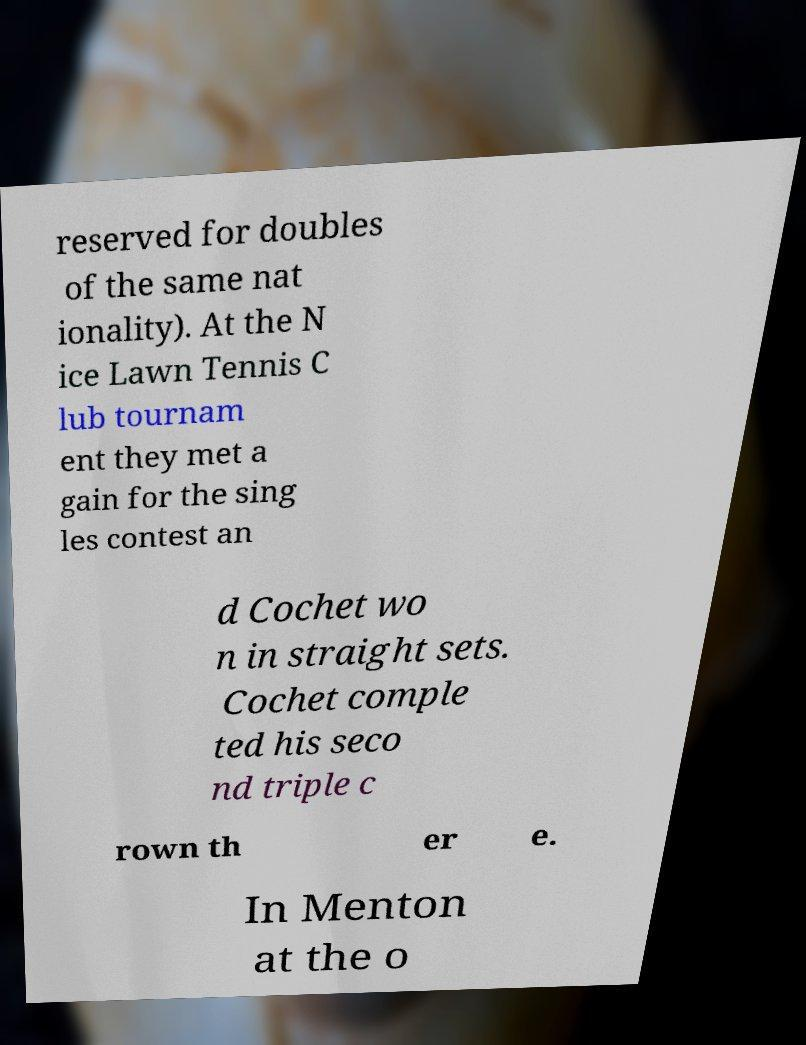There's text embedded in this image that I need extracted. Can you transcribe it verbatim? reserved for doubles of the same nat ionality). At the N ice Lawn Tennis C lub tournam ent they met a gain for the sing les contest an d Cochet wo n in straight sets. Cochet comple ted his seco nd triple c rown th er e. In Menton at the o 